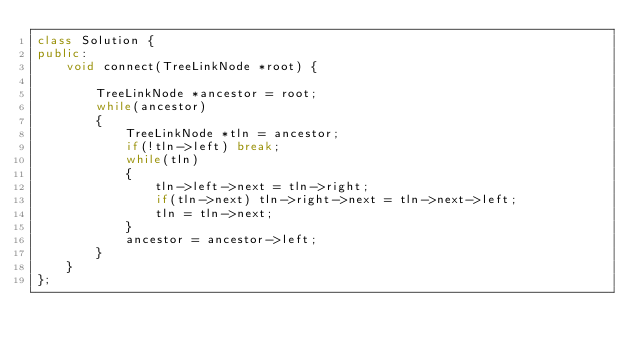<code> <loc_0><loc_0><loc_500><loc_500><_C++_>class Solution {
public:
    void connect(TreeLinkNode *root) {

        TreeLinkNode *ancestor = root;
        while(ancestor)
        {
            TreeLinkNode *tln = ancestor;
            if(!tln->left) break;
            while(tln)
            {
                tln->left->next = tln->right;
                if(tln->next) tln->right->next = tln->next->left;
                tln = tln->next;
            }
            ancestor = ancestor->left;
        }
    }
};
</code> 